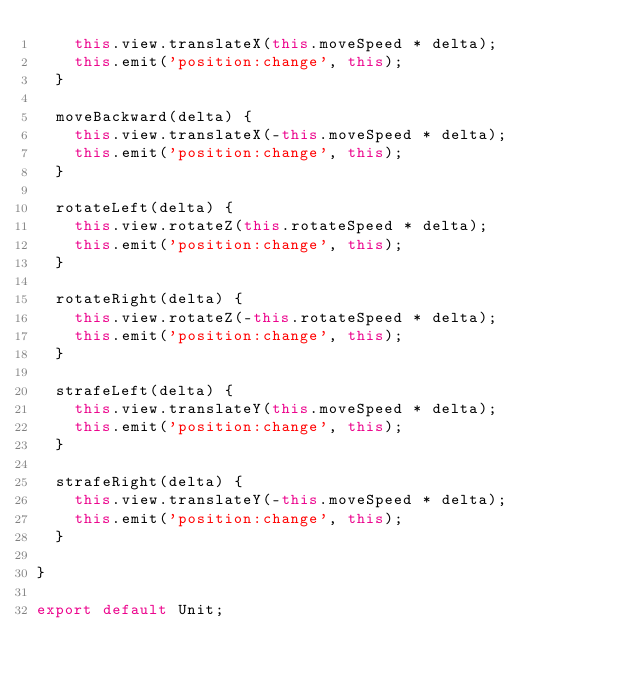<code> <loc_0><loc_0><loc_500><loc_500><_JavaScript_>    this.view.translateX(this.moveSpeed * delta);
    this.emit('position:change', this);
  }

  moveBackward(delta) {
    this.view.translateX(-this.moveSpeed * delta);
    this.emit('position:change', this);
  }

  rotateLeft(delta) {
    this.view.rotateZ(this.rotateSpeed * delta);
    this.emit('position:change', this);
  }

  rotateRight(delta) {
    this.view.rotateZ(-this.rotateSpeed * delta);
    this.emit('position:change', this);
  }

  strafeLeft(delta) {
    this.view.translateY(this.moveSpeed * delta);
    this.emit('position:change', this);
  }

  strafeRight(delta) {
    this.view.translateY(-this.moveSpeed * delta);
    this.emit('position:change', this);
  }

}

export default Unit;
</code> 